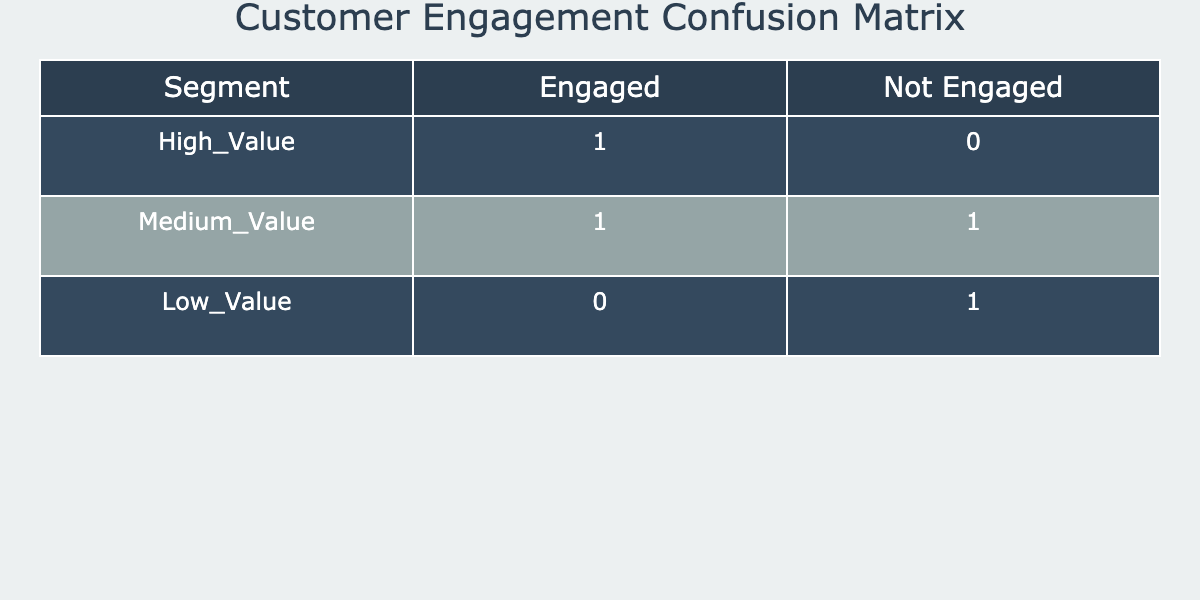What is the number of High_Value customers that were engaged? In the table, for High_Value customers with the Expected Engagement as Engaged, the Actual Engagement is also Engaged. This shows that there is 1 High_Value customer that is counted under engaged. Thus, there is 1 customer.
Answer: 1 How many Medium_Value customers were not engaged? The row for Medium_Value customers with Expected Engagement as Not_Engaged and Actual Engagement also as Not_Engaged shows a total of 1 customer. Therefore, there is 1 customer that fits this criterion.
Answer: 1 Are there any Low_Value customers that were engaged? Looking at the rows related to Low_Value customers, the combination of Expected Engagement as Engaged and Actual Engagement as Engaged shows 0 customers. However, if we check the row where the Expected Engagement is Not_Engaged and the Actual Engagement is Engaged, there is also a 0, which means there are no Low_Value customers engaged.
Answer: No What is the total number of engaged customers across all segments? To determine this, we need to sum the values of engaged customers in all segments. From the table, it's 1 (High_Value) + 1 (Medium_Value) + 0 (Low_Value) = 2 engaged customers in total across all segments.
Answer: 2 How many customers are there in the Low_Value segment that are not engaged? In the table, for the Low_Value segment, Expected Engagement as Not_Engaged and Actual Engagement also as Not_Engaged shows 1 customer. Therefore, there is 1 customer in the Low_Value segment that is not engaged.
Answer: 1 Is it true that all customers in the Medium_Value segment were engaged? If we examine the Medium_Value segment, under Expected Engagement as Engaged there is one count of Not_Engaged, which indicates that not all Medium_Value customers were engaged. Therefore, this statement is false.
Answer: No What is the difference in the number of engaged Low_Value customers compared to Medium_Value customers? After counting from the table, Low_Value shows 0 engaged customers (Expected Engaged matches with Not Engaged) while Medium_Value shows 1 engaged customer (Expected Engaged matches with Engaged). Therefore, the difference is 1 - 0 = 1.
Answer: 1 What percentage of High_Value customers were engaged compared to the total number of High_Value customers? There are a total of 2 High_Value customers (1 engaged and 1 not engaged). The percentage engaged is thus (1 engaged customer / 2 total customers) * 100 = 50%. Therefore, 50% of High_Value customers were engaged.
Answer: 50% How many not engaged customers are there in total across all segments? By checking each row for not engaged customers across all segments, Low_Value has 1 (Not Engaged), High_Value has 1 (Not Engaged), and Medium_Value has 1 (Not Engaged), giving a total of 3 not engaged customers across all segments.
Answer: 3 